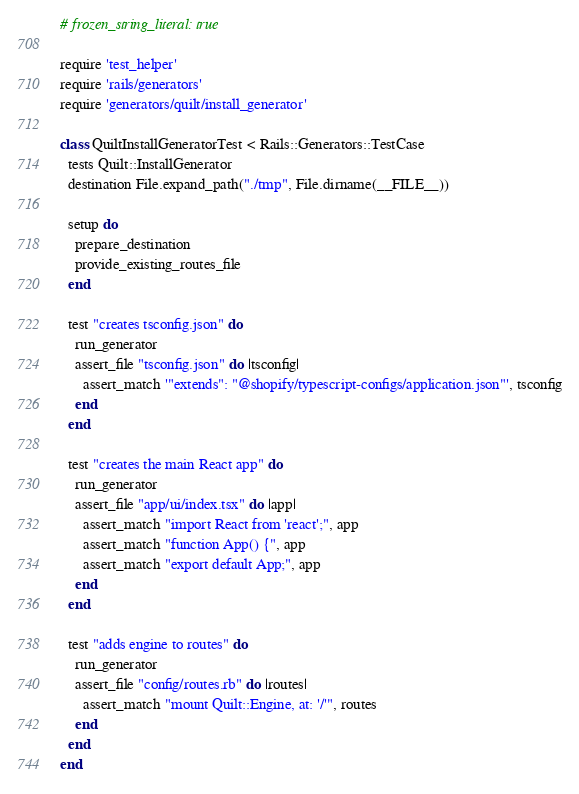Convert code to text. <code><loc_0><loc_0><loc_500><loc_500><_Ruby_># frozen_string_literal: true

require 'test_helper'
require 'rails/generators'
require 'generators/quilt/install_generator'

class QuiltInstallGeneratorTest < Rails::Generators::TestCase
  tests Quilt::InstallGenerator
  destination File.expand_path("./tmp", File.dirname(__FILE__))

  setup do
    prepare_destination
    provide_existing_routes_file
  end

  test "creates tsconfig.json" do
    run_generator
    assert_file "tsconfig.json" do |tsconfig|
      assert_match '"extends": "@shopify/typescript-configs/application.json"', tsconfig
    end
  end

  test "creates the main React app" do
    run_generator
    assert_file "app/ui/index.tsx" do |app|
      assert_match "import React from 'react';", app
      assert_match "function App() {", app
      assert_match "export default App;", app
    end
  end

  test "adds engine to routes" do
    run_generator
    assert_file "config/routes.rb" do |routes|
      assert_match "mount Quilt::Engine, at: '/'", routes
    end
  end
end
</code> 